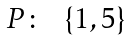<formula> <loc_0><loc_0><loc_500><loc_500>\begin{array} { c c c } P \colon & \{ 1 , 5 \} \\ \end{array}</formula> 